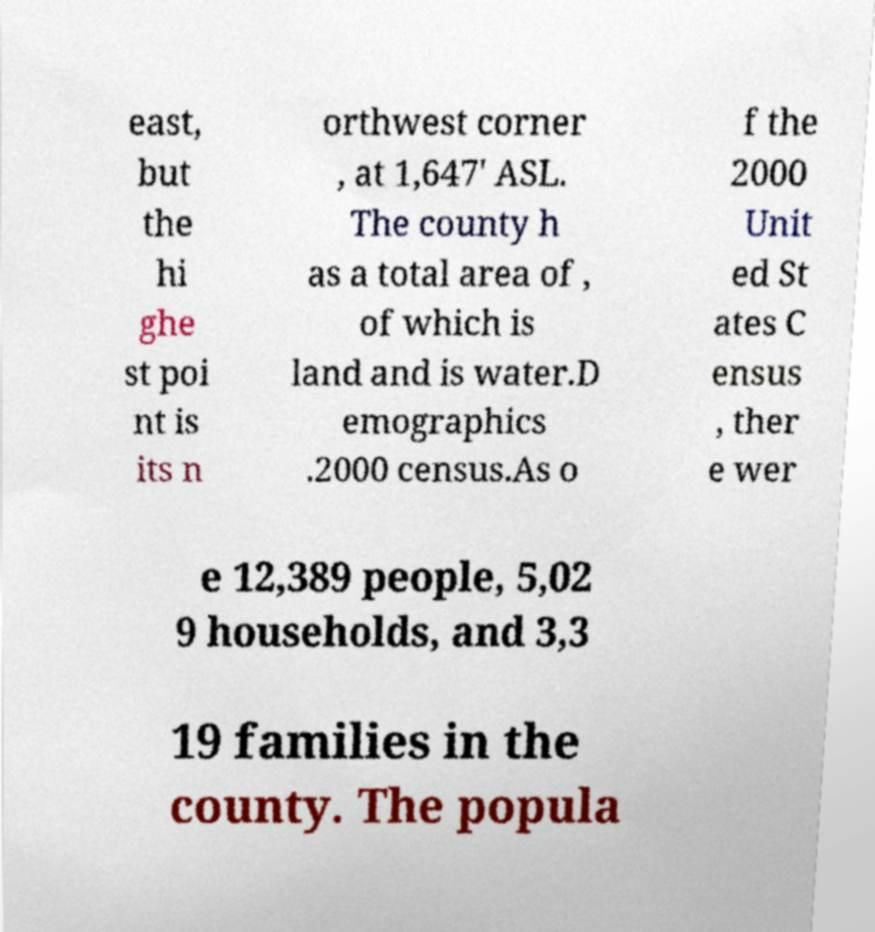Could you assist in decoding the text presented in this image and type it out clearly? east, but the hi ghe st poi nt is its n orthwest corner , at 1,647' ASL. The county h as a total area of , of which is land and is water.D emographics .2000 census.As o f the 2000 Unit ed St ates C ensus , ther e wer e 12,389 people, 5,02 9 households, and 3,3 19 families in the county. The popula 